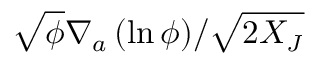<formula> <loc_0><loc_0><loc_500><loc_500>\sqrt { \phi } { \nabla _ { a } \left ( \ln { \phi } \right ) } / { \sqrt { 2 X _ { J } } }</formula> 